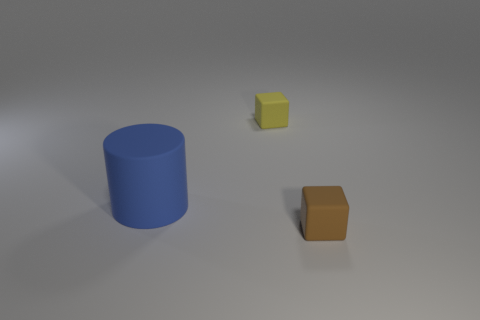What is the material of the other small thing that is the same shape as the small yellow object?
Keep it short and to the point. Rubber. Is the size of the blue object that is on the left side of the yellow object the same as the yellow thing?
Give a very brief answer. No. How many rubber objects are either tiny green spheres or yellow blocks?
Give a very brief answer. 1. What is the object that is behind the brown block and in front of the tiny yellow cube made of?
Offer a terse response. Rubber. Are the yellow block and the blue thing made of the same material?
Ensure brevity in your answer.  Yes. What size is the rubber object that is on the right side of the big object and on the left side of the brown matte thing?
Give a very brief answer. Small. There is a brown rubber thing; what shape is it?
Your answer should be compact. Cube. What number of objects are tiny brown rubber cubes or tiny objects in front of the cylinder?
Offer a very short reply. 1. There is a tiny matte object on the right side of the yellow object; is it the same color as the big cylinder?
Keep it short and to the point. No. There is a rubber thing that is both behind the brown rubber thing and in front of the tiny yellow cube; what color is it?
Keep it short and to the point. Blue. 